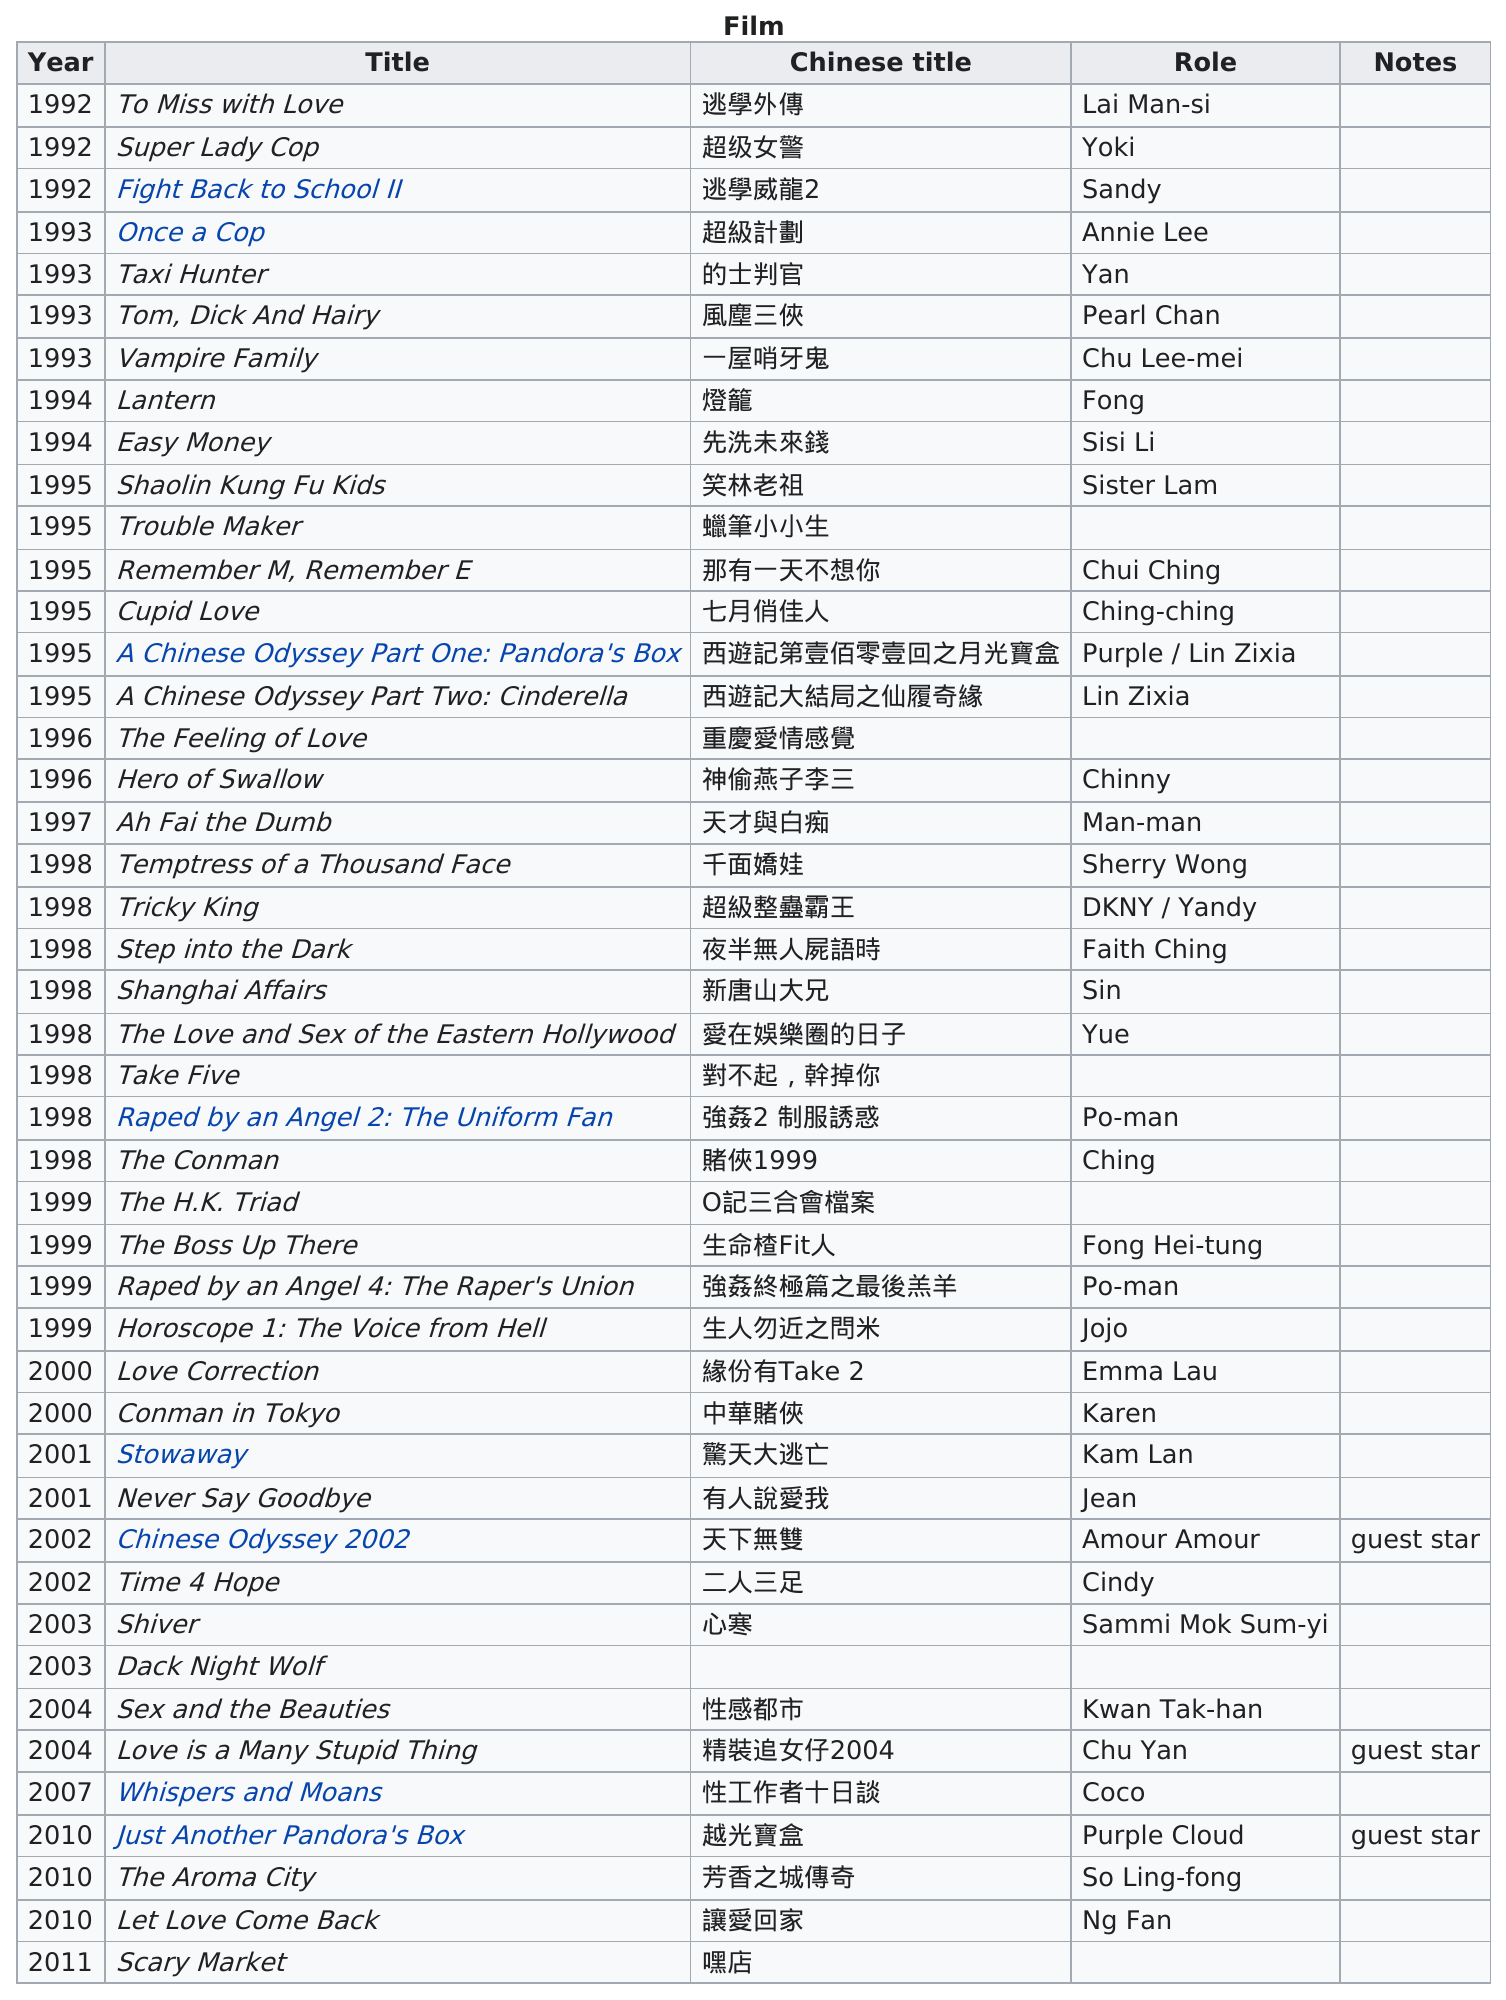List a handful of essential elements in this visual. Athena Chu's first role was played by Lai Man-si. In which year did she work on the most films? That would be 1998. As of my knowledge cutoff date in September 2021, Athena Chu has acted in a total of 45 films. After the successful release of "Hero of Swallow," the next film that Tony Leung Chiu Wai worked on was "Ah Fai the Dumb. In 1998, she appeared in 8 movies. 